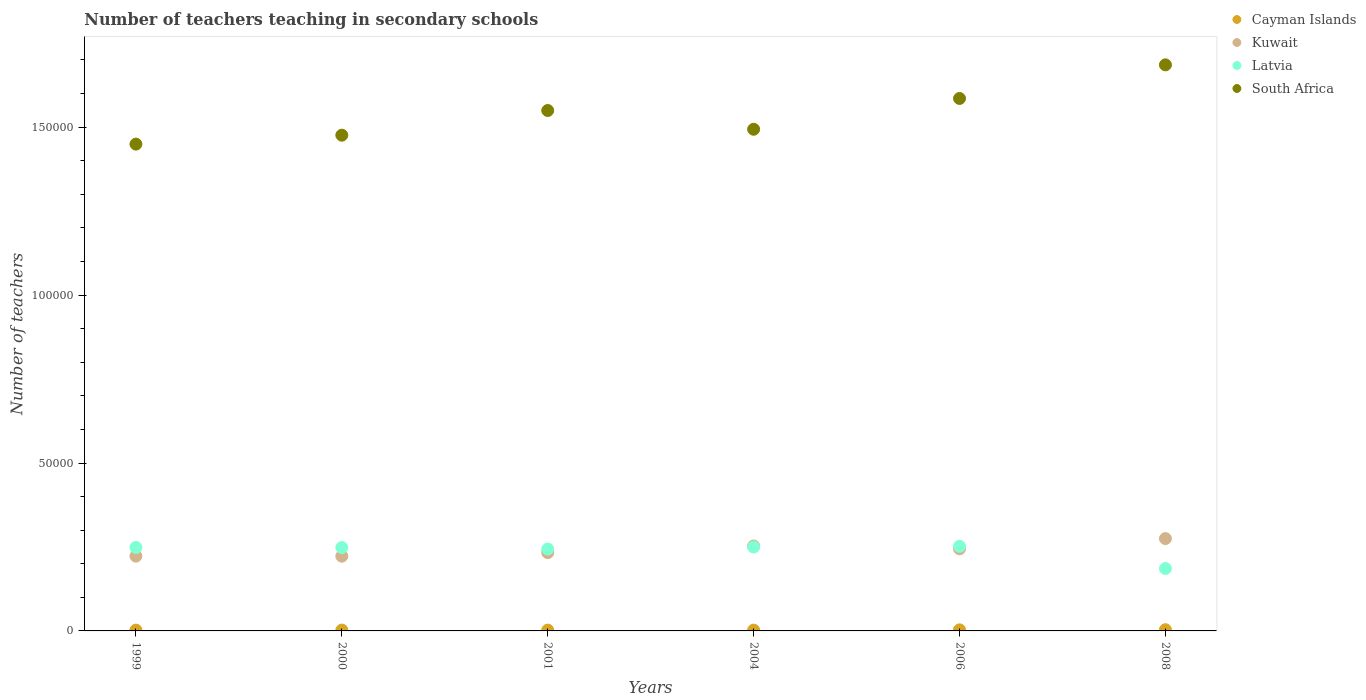How many different coloured dotlines are there?
Your answer should be compact. 4. What is the number of teachers teaching in secondary schools in Latvia in 2008?
Provide a succinct answer. 1.86e+04. Across all years, what is the maximum number of teachers teaching in secondary schools in Kuwait?
Your answer should be compact. 2.75e+04. Across all years, what is the minimum number of teachers teaching in secondary schools in Latvia?
Provide a succinct answer. 1.86e+04. In which year was the number of teachers teaching in secondary schools in Latvia minimum?
Your answer should be compact. 2008. What is the total number of teachers teaching in secondary schools in South Africa in the graph?
Keep it short and to the point. 9.24e+05. What is the difference between the number of teachers teaching in secondary schools in South Africa in 1999 and that in 2008?
Provide a short and direct response. -2.36e+04. What is the difference between the number of teachers teaching in secondary schools in Kuwait in 2004 and the number of teachers teaching in secondary schools in Cayman Islands in 2008?
Provide a succinct answer. 2.49e+04. What is the average number of teachers teaching in secondary schools in Cayman Islands per year?
Provide a succinct answer. 274. In the year 2006, what is the difference between the number of teachers teaching in secondary schools in Cayman Islands and number of teachers teaching in secondary schools in Kuwait?
Your response must be concise. -2.41e+04. What is the ratio of the number of teachers teaching in secondary schools in Kuwait in 2006 to that in 2008?
Make the answer very short. 0.89. What is the difference between the highest and the second highest number of teachers teaching in secondary schools in Latvia?
Ensure brevity in your answer.  213. What is the difference between the highest and the lowest number of teachers teaching in secondary schools in Latvia?
Make the answer very short. 6627. In how many years, is the number of teachers teaching in secondary schools in Kuwait greater than the average number of teachers teaching in secondary schools in Kuwait taken over all years?
Your answer should be compact. 3. Is it the case that in every year, the sum of the number of teachers teaching in secondary schools in South Africa and number of teachers teaching in secondary schools in Cayman Islands  is greater than the sum of number of teachers teaching in secondary schools in Kuwait and number of teachers teaching in secondary schools in Latvia?
Give a very brief answer. Yes. Does the number of teachers teaching in secondary schools in Latvia monotonically increase over the years?
Keep it short and to the point. No. What is the difference between two consecutive major ticks on the Y-axis?
Offer a terse response. 5.00e+04. Are the values on the major ticks of Y-axis written in scientific E-notation?
Your response must be concise. No. Does the graph contain any zero values?
Keep it short and to the point. No. Does the graph contain grids?
Make the answer very short. No. How many legend labels are there?
Keep it short and to the point. 4. How are the legend labels stacked?
Your answer should be very brief. Vertical. What is the title of the graph?
Provide a short and direct response. Number of teachers teaching in secondary schools. Does "Moldova" appear as one of the legend labels in the graph?
Your response must be concise. No. What is the label or title of the Y-axis?
Ensure brevity in your answer.  Number of teachers. What is the Number of teachers in Cayman Islands in 1999?
Offer a very short reply. 237. What is the Number of teachers in Kuwait in 1999?
Provide a short and direct response. 2.23e+04. What is the Number of teachers in Latvia in 1999?
Make the answer very short. 2.48e+04. What is the Number of teachers of South Africa in 1999?
Your response must be concise. 1.45e+05. What is the Number of teachers of Cayman Islands in 2000?
Offer a terse response. 252. What is the Number of teachers in Kuwait in 2000?
Make the answer very short. 2.22e+04. What is the Number of teachers in Latvia in 2000?
Your answer should be very brief. 2.48e+04. What is the Number of teachers in South Africa in 2000?
Ensure brevity in your answer.  1.48e+05. What is the Number of teachers in Cayman Islands in 2001?
Offer a very short reply. 239. What is the Number of teachers in Kuwait in 2001?
Your answer should be compact. 2.33e+04. What is the Number of teachers of Latvia in 2001?
Provide a succinct answer. 2.44e+04. What is the Number of teachers in South Africa in 2001?
Provide a succinct answer. 1.55e+05. What is the Number of teachers in Cayman Islands in 2004?
Give a very brief answer. 239. What is the Number of teachers in Kuwait in 2004?
Give a very brief answer. 2.53e+04. What is the Number of teachers in Latvia in 2004?
Your answer should be compact. 2.50e+04. What is the Number of teachers in South Africa in 2004?
Your answer should be very brief. 1.49e+05. What is the Number of teachers of Cayman Islands in 2006?
Your answer should be compact. 316. What is the Number of teachers in Kuwait in 2006?
Your response must be concise. 2.44e+04. What is the Number of teachers in Latvia in 2006?
Your response must be concise. 2.52e+04. What is the Number of teachers of South Africa in 2006?
Make the answer very short. 1.59e+05. What is the Number of teachers of Cayman Islands in 2008?
Keep it short and to the point. 361. What is the Number of teachers of Kuwait in 2008?
Ensure brevity in your answer.  2.75e+04. What is the Number of teachers in Latvia in 2008?
Offer a very short reply. 1.86e+04. What is the Number of teachers of South Africa in 2008?
Give a very brief answer. 1.69e+05. Across all years, what is the maximum Number of teachers of Cayman Islands?
Provide a succinct answer. 361. Across all years, what is the maximum Number of teachers in Kuwait?
Make the answer very short. 2.75e+04. Across all years, what is the maximum Number of teachers of Latvia?
Your answer should be compact. 2.52e+04. Across all years, what is the maximum Number of teachers of South Africa?
Keep it short and to the point. 1.69e+05. Across all years, what is the minimum Number of teachers of Cayman Islands?
Your answer should be compact. 237. Across all years, what is the minimum Number of teachers of Kuwait?
Your response must be concise. 2.22e+04. Across all years, what is the minimum Number of teachers in Latvia?
Give a very brief answer. 1.86e+04. Across all years, what is the minimum Number of teachers of South Africa?
Your answer should be compact. 1.45e+05. What is the total Number of teachers of Cayman Islands in the graph?
Offer a very short reply. 1644. What is the total Number of teachers of Kuwait in the graph?
Offer a very short reply. 1.45e+05. What is the total Number of teachers in Latvia in the graph?
Your answer should be compact. 1.43e+05. What is the total Number of teachers in South Africa in the graph?
Offer a very short reply. 9.24e+05. What is the difference between the Number of teachers of Kuwait in 1999 and that in 2000?
Give a very brief answer. 20. What is the difference between the Number of teachers of South Africa in 1999 and that in 2000?
Provide a short and direct response. -2663. What is the difference between the Number of teachers of Kuwait in 1999 and that in 2001?
Ensure brevity in your answer.  -1047. What is the difference between the Number of teachers of Latvia in 1999 and that in 2001?
Your answer should be compact. 463. What is the difference between the Number of teachers in South Africa in 1999 and that in 2001?
Your answer should be very brief. -1.00e+04. What is the difference between the Number of teachers in Kuwait in 1999 and that in 2004?
Your response must be concise. -3026. What is the difference between the Number of teachers in Latvia in 1999 and that in 2004?
Your response must be concise. -140. What is the difference between the Number of teachers of South Africa in 1999 and that in 2004?
Provide a succinct answer. -4426. What is the difference between the Number of teachers in Cayman Islands in 1999 and that in 2006?
Your answer should be compact. -79. What is the difference between the Number of teachers of Kuwait in 1999 and that in 2006?
Your response must be concise. -2178. What is the difference between the Number of teachers of Latvia in 1999 and that in 2006?
Provide a short and direct response. -353. What is the difference between the Number of teachers of South Africa in 1999 and that in 2006?
Your answer should be very brief. -1.36e+04. What is the difference between the Number of teachers of Cayman Islands in 1999 and that in 2008?
Give a very brief answer. -124. What is the difference between the Number of teachers of Kuwait in 1999 and that in 2008?
Ensure brevity in your answer.  -5232. What is the difference between the Number of teachers in Latvia in 1999 and that in 2008?
Provide a short and direct response. 6274. What is the difference between the Number of teachers of South Africa in 1999 and that in 2008?
Your answer should be compact. -2.36e+04. What is the difference between the Number of teachers of Kuwait in 2000 and that in 2001?
Provide a succinct answer. -1067. What is the difference between the Number of teachers of Latvia in 2000 and that in 2001?
Provide a short and direct response. 433. What is the difference between the Number of teachers of South Africa in 2000 and that in 2001?
Offer a terse response. -7348. What is the difference between the Number of teachers in Kuwait in 2000 and that in 2004?
Provide a succinct answer. -3046. What is the difference between the Number of teachers in Latvia in 2000 and that in 2004?
Your response must be concise. -170. What is the difference between the Number of teachers of South Africa in 2000 and that in 2004?
Ensure brevity in your answer.  -1763. What is the difference between the Number of teachers in Cayman Islands in 2000 and that in 2006?
Provide a succinct answer. -64. What is the difference between the Number of teachers in Kuwait in 2000 and that in 2006?
Provide a short and direct response. -2198. What is the difference between the Number of teachers in Latvia in 2000 and that in 2006?
Offer a terse response. -383. What is the difference between the Number of teachers in South Africa in 2000 and that in 2006?
Your response must be concise. -1.09e+04. What is the difference between the Number of teachers of Cayman Islands in 2000 and that in 2008?
Ensure brevity in your answer.  -109. What is the difference between the Number of teachers in Kuwait in 2000 and that in 2008?
Your answer should be very brief. -5252. What is the difference between the Number of teachers in Latvia in 2000 and that in 2008?
Offer a very short reply. 6244. What is the difference between the Number of teachers in South Africa in 2000 and that in 2008?
Provide a succinct answer. -2.09e+04. What is the difference between the Number of teachers of Cayman Islands in 2001 and that in 2004?
Offer a very short reply. 0. What is the difference between the Number of teachers of Kuwait in 2001 and that in 2004?
Offer a terse response. -1979. What is the difference between the Number of teachers of Latvia in 2001 and that in 2004?
Make the answer very short. -603. What is the difference between the Number of teachers in South Africa in 2001 and that in 2004?
Your response must be concise. 5585. What is the difference between the Number of teachers in Cayman Islands in 2001 and that in 2006?
Give a very brief answer. -77. What is the difference between the Number of teachers of Kuwait in 2001 and that in 2006?
Keep it short and to the point. -1131. What is the difference between the Number of teachers in Latvia in 2001 and that in 2006?
Ensure brevity in your answer.  -816. What is the difference between the Number of teachers in South Africa in 2001 and that in 2006?
Offer a terse response. -3584. What is the difference between the Number of teachers in Cayman Islands in 2001 and that in 2008?
Provide a succinct answer. -122. What is the difference between the Number of teachers in Kuwait in 2001 and that in 2008?
Your answer should be compact. -4185. What is the difference between the Number of teachers in Latvia in 2001 and that in 2008?
Offer a terse response. 5811. What is the difference between the Number of teachers in South Africa in 2001 and that in 2008?
Provide a succinct answer. -1.36e+04. What is the difference between the Number of teachers of Cayman Islands in 2004 and that in 2006?
Ensure brevity in your answer.  -77. What is the difference between the Number of teachers in Kuwait in 2004 and that in 2006?
Provide a succinct answer. 848. What is the difference between the Number of teachers of Latvia in 2004 and that in 2006?
Make the answer very short. -213. What is the difference between the Number of teachers of South Africa in 2004 and that in 2006?
Give a very brief answer. -9169. What is the difference between the Number of teachers in Cayman Islands in 2004 and that in 2008?
Your answer should be very brief. -122. What is the difference between the Number of teachers of Kuwait in 2004 and that in 2008?
Give a very brief answer. -2206. What is the difference between the Number of teachers in Latvia in 2004 and that in 2008?
Offer a terse response. 6414. What is the difference between the Number of teachers of South Africa in 2004 and that in 2008?
Give a very brief answer. -1.92e+04. What is the difference between the Number of teachers of Cayman Islands in 2006 and that in 2008?
Provide a short and direct response. -45. What is the difference between the Number of teachers of Kuwait in 2006 and that in 2008?
Offer a very short reply. -3054. What is the difference between the Number of teachers in Latvia in 2006 and that in 2008?
Provide a succinct answer. 6627. What is the difference between the Number of teachers in South Africa in 2006 and that in 2008?
Ensure brevity in your answer.  -1.00e+04. What is the difference between the Number of teachers of Cayman Islands in 1999 and the Number of teachers of Kuwait in 2000?
Your response must be concise. -2.20e+04. What is the difference between the Number of teachers in Cayman Islands in 1999 and the Number of teachers in Latvia in 2000?
Ensure brevity in your answer.  -2.46e+04. What is the difference between the Number of teachers in Cayman Islands in 1999 and the Number of teachers in South Africa in 2000?
Offer a terse response. -1.47e+05. What is the difference between the Number of teachers in Kuwait in 1999 and the Number of teachers in Latvia in 2000?
Offer a very short reply. -2555. What is the difference between the Number of teachers of Kuwait in 1999 and the Number of teachers of South Africa in 2000?
Offer a terse response. -1.25e+05. What is the difference between the Number of teachers of Latvia in 1999 and the Number of teachers of South Africa in 2000?
Your answer should be compact. -1.23e+05. What is the difference between the Number of teachers of Cayman Islands in 1999 and the Number of teachers of Kuwait in 2001?
Provide a short and direct response. -2.31e+04. What is the difference between the Number of teachers in Cayman Islands in 1999 and the Number of teachers in Latvia in 2001?
Your answer should be compact. -2.41e+04. What is the difference between the Number of teachers in Cayman Islands in 1999 and the Number of teachers in South Africa in 2001?
Keep it short and to the point. -1.55e+05. What is the difference between the Number of teachers in Kuwait in 1999 and the Number of teachers in Latvia in 2001?
Provide a succinct answer. -2122. What is the difference between the Number of teachers in Kuwait in 1999 and the Number of teachers in South Africa in 2001?
Give a very brief answer. -1.33e+05. What is the difference between the Number of teachers of Latvia in 1999 and the Number of teachers of South Africa in 2001?
Ensure brevity in your answer.  -1.30e+05. What is the difference between the Number of teachers in Cayman Islands in 1999 and the Number of teachers in Kuwait in 2004?
Provide a succinct answer. -2.51e+04. What is the difference between the Number of teachers in Cayman Islands in 1999 and the Number of teachers in Latvia in 2004?
Your response must be concise. -2.48e+04. What is the difference between the Number of teachers in Cayman Islands in 1999 and the Number of teachers in South Africa in 2004?
Ensure brevity in your answer.  -1.49e+05. What is the difference between the Number of teachers in Kuwait in 1999 and the Number of teachers in Latvia in 2004?
Make the answer very short. -2725. What is the difference between the Number of teachers of Kuwait in 1999 and the Number of teachers of South Africa in 2004?
Provide a succinct answer. -1.27e+05. What is the difference between the Number of teachers in Latvia in 1999 and the Number of teachers in South Africa in 2004?
Provide a succinct answer. -1.25e+05. What is the difference between the Number of teachers in Cayman Islands in 1999 and the Number of teachers in Kuwait in 2006?
Make the answer very short. -2.42e+04. What is the difference between the Number of teachers of Cayman Islands in 1999 and the Number of teachers of Latvia in 2006?
Give a very brief answer. -2.50e+04. What is the difference between the Number of teachers in Cayman Islands in 1999 and the Number of teachers in South Africa in 2006?
Offer a terse response. -1.58e+05. What is the difference between the Number of teachers in Kuwait in 1999 and the Number of teachers in Latvia in 2006?
Give a very brief answer. -2938. What is the difference between the Number of teachers in Kuwait in 1999 and the Number of teachers in South Africa in 2006?
Keep it short and to the point. -1.36e+05. What is the difference between the Number of teachers in Latvia in 1999 and the Number of teachers in South Africa in 2006?
Give a very brief answer. -1.34e+05. What is the difference between the Number of teachers in Cayman Islands in 1999 and the Number of teachers in Kuwait in 2008?
Make the answer very short. -2.73e+04. What is the difference between the Number of teachers of Cayman Islands in 1999 and the Number of teachers of Latvia in 2008?
Provide a succinct answer. -1.83e+04. What is the difference between the Number of teachers in Cayman Islands in 1999 and the Number of teachers in South Africa in 2008?
Provide a short and direct response. -1.68e+05. What is the difference between the Number of teachers of Kuwait in 1999 and the Number of teachers of Latvia in 2008?
Offer a terse response. 3689. What is the difference between the Number of teachers of Kuwait in 1999 and the Number of teachers of South Africa in 2008?
Offer a terse response. -1.46e+05. What is the difference between the Number of teachers of Latvia in 1999 and the Number of teachers of South Africa in 2008?
Your answer should be very brief. -1.44e+05. What is the difference between the Number of teachers of Cayman Islands in 2000 and the Number of teachers of Kuwait in 2001?
Your answer should be compact. -2.31e+04. What is the difference between the Number of teachers of Cayman Islands in 2000 and the Number of teachers of Latvia in 2001?
Give a very brief answer. -2.41e+04. What is the difference between the Number of teachers in Cayman Islands in 2000 and the Number of teachers in South Africa in 2001?
Offer a terse response. -1.55e+05. What is the difference between the Number of teachers of Kuwait in 2000 and the Number of teachers of Latvia in 2001?
Your answer should be very brief. -2142. What is the difference between the Number of teachers of Kuwait in 2000 and the Number of teachers of South Africa in 2001?
Ensure brevity in your answer.  -1.33e+05. What is the difference between the Number of teachers of Latvia in 2000 and the Number of teachers of South Africa in 2001?
Give a very brief answer. -1.30e+05. What is the difference between the Number of teachers in Cayman Islands in 2000 and the Number of teachers in Kuwait in 2004?
Keep it short and to the point. -2.50e+04. What is the difference between the Number of teachers of Cayman Islands in 2000 and the Number of teachers of Latvia in 2004?
Your answer should be compact. -2.47e+04. What is the difference between the Number of teachers of Cayman Islands in 2000 and the Number of teachers of South Africa in 2004?
Your response must be concise. -1.49e+05. What is the difference between the Number of teachers in Kuwait in 2000 and the Number of teachers in Latvia in 2004?
Make the answer very short. -2745. What is the difference between the Number of teachers of Kuwait in 2000 and the Number of teachers of South Africa in 2004?
Your answer should be compact. -1.27e+05. What is the difference between the Number of teachers of Latvia in 2000 and the Number of teachers of South Africa in 2004?
Your answer should be very brief. -1.25e+05. What is the difference between the Number of teachers of Cayman Islands in 2000 and the Number of teachers of Kuwait in 2006?
Your response must be concise. -2.42e+04. What is the difference between the Number of teachers in Cayman Islands in 2000 and the Number of teachers in Latvia in 2006?
Provide a succinct answer. -2.50e+04. What is the difference between the Number of teachers of Cayman Islands in 2000 and the Number of teachers of South Africa in 2006?
Your answer should be compact. -1.58e+05. What is the difference between the Number of teachers in Kuwait in 2000 and the Number of teachers in Latvia in 2006?
Provide a succinct answer. -2958. What is the difference between the Number of teachers in Kuwait in 2000 and the Number of teachers in South Africa in 2006?
Provide a short and direct response. -1.36e+05. What is the difference between the Number of teachers of Latvia in 2000 and the Number of teachers of South Africa in 2006?
Give a very brief answer. -1.34e+05. What is the difference between the Number of teachers in Cayman Islands in 2000 and the Number of teachers in Kuwait in 2008?
Provide a succinct answer. -2.72e+04. What is the difference between the Number of teachers in Cayman Islands in 2000 and the Number of teachers in Latvia in 2008?
Offer a very short reply. -1.83e+04. What is the difference between the Number of teachers of Cayman Islands in 2000 and the Number of teachers of South Africa in 2008?
Your response must be concise. -1.68e+05. What is the difference between the Number of teachers in Kuwait in 2000 and the Number of teachers in Latvia in 2008?
Offer a terse response. 3669. What is the difference between the Number of teachers of Kuwait in 2000 and the Number of teachers of South Africa in 2008?
Your response must be concise. -1.46e+05. What is the difference between the Number of teachers in Latvia in 2000 and the Number of teachers in South Africa in 2008?
Your answer should be very brief. -1.44e+05. What is the difference between the Number of teachers of Cayman Islands in 2001 and the Number of teachers of Kuwait in 2004?
Offer a very short reply. -2.51e+04. What is the difference between the Number of teachers in Cayman Islands in 2001 and the Number of teachers in Latvia in 2004?
Your answer should be very brief. -2.48e+04. What is the difference between the Number of teachers in Cayman Islands in 2001 and the Number of teachers in South Africa in 2004?
Give a very brief answer. -1.49e+05. What is the difference between the Number of teachers of Kuwait in 2001 and the Number of teachers of Latvia in 2004?
Provide a succinct answer. -1678. What is the difference between the Number of teachers of Kuwait in 2001 and the Number of teachers of South Africa in 2004?
Offer a terse response. -1.26e+05. What is the difference between the Number of teachers of Latvia in 2001 and the Number of teachers of South Africa in 2004?
Offer a terse response. -1.25e+05. What is the difference between the Number of teachers in Cayman Islands in 2001 and the Number of teachers in Kuwait in 2006?
Ensure brevity in your answer.  -2.42e+04. What is the difference between the Number of teachers in Cayman Islands in 2001 and the Number of teachers in Latvia in 2006?
Your answer should be very brief. -2.50e+04. What is the difference between the Number of teachers of Cayman Islands in 2001 and the Number of teachers of South Africa in 2006?
Keep it short and to the point. -1.58e+05. What is the difference between the Number of teachers in Kuwait in 2001 and the Number of teachers in Latvia in 2006?
Your response must be concise. -1891. What is the difference between the Number of teachers of Kuwait in 2001 and the Number of teachers of South Africa in 2006?
Offer a very short reply. -1.35e+05. What is the difference between the Number of teachers of Latvia in 2001 and the Number of teachers of South Africa in 2006?
Provide a short and direct response. -1.34e+05. What is the difference between the Number of teachers in Cayman Islands in 2001 and the Number of teachers in Kuwait in 2008?
Your answer should be compact. -2.73e+04. What is the difference between the Number of teachers of Cayman Islands in 2001 and the Number of teachers of Latvia in 2008?
Give a very brief answer. -1.83e+04. What is the difference between the Number of teachers of Cayman Islands in 2001 and the Number of teachers of South Africa in 2008?
Your answer should be very brief. -1.68e+05. What is the difference between the Number of teachers of Kuwait in 2001 and the Number of teachers of Latvia in 2008?
Provide a succinct answer. 4736. What is the difference between the Number of teachers in Kuwait in 2001 and the Number of teachers in South Africa in 2008?
Provide a short and direct response. -1.45e+05. What is the difference between the Number of teachers in Latvia in 2001 and the Number of teachers in South Africa in 2008?
Provide a short and direct response. -1.44e+05. What is the difference between the Number of teachers in Cayman Islands in 2004 and the Number of teachers in Kuwait in 2006?
Make the answer very short. -2.42e+04. What is the difference between the Number of teachers of Cayman Islands in 2004 and the Number of teachers of Latvia in 2006?
Make the answer very short. -2.50e+04. What is the difference between the Number of teachers of Cayman Islands in 2004 and the Number of teachers of South Africa in 2006?
Give a very brief answer. -1.58e+05. What is the difference between the Number of teachers in Kuwait in 2004 and the Number of teachers in Latvia in 2006?
Your answer should be very brief. 88. What is the difference between the Number of teachers in Kuwait in 2004 and the Number of teachers in South Africa in 2006?
Offer a terse response. -1.33e+05. What is the difference between the Number of teachers in Latvia in 2004 and the Number of teachers in South Africa in 2006?
Make the answer very short. -1.34e+05. What is the difference between the Number of teachers in Cayman Islands in 2004 and the Number of teachers in Kuwait in 2008?
Ensure brevity in your answer.  -2.73e+04. What is the difference between the Number of teachers in Cayman Islands in 2004 and the Number of teachers in Latvia in 2008?
Your answer should be compact. -1.83e+04. What is the difference between the Number of teachers in Cayman Islands in 2004 and the Number of teachers in South Africa in 2008?
Provide a short and direct response. -1.68e+05. What is the difference between the Number of teachers of Kuwait in 2004 and the Number of teachers of Latvia in 2008?
Provide a succinct answer. 6715. What is the difference between the Number of teachers in Kuwait in 2004 and the Number of teachers in South Africa in 2008?
Ensure brevity in your answer.  -1.43e+05. What is the difference between the Number of teachers in Latvia in 2004 and the Number of teachers in South Africa in 2008?
Provide a succinct answer. -1.44e+05. What is the difference between the Number of teachers of Cayman Islands in 2006 and the Number of teachers of Kuwait in 2008?
Provide a succinct answer. -2.72e+04. What is the difference between the Number of teachers in Cayman Islands in 2006 and the Number of teachers in Latvia in 2008?
Ensure brevity in your answer.  -1.83e+04. What is the difference between the Number of teachers of Cayman Islands in 2006 and the Number of teachers of South Africa in 2008?
Make the answer very short. -1.68e+05. What is the difference between the Number of teachers of Kuwait in 2006 and the Number of teachers of Latvia in 2008?
Provide a short and direct response. 5867. What is the difference between the Number of teachers of Kuwait in 2006 and the Number of teachers of South Africa in 2008?
Give a very brief answer. -1.44e+05. What is the difference between the Number of teachers of Latvia in 2006 and the Number of teachers of South Africa in 2008?
Offer a terse response. -1.43e+05. What is the average Number of teachers in Cayman Islands per year?
Keep it short and to the point. 274. What is the average Number of teachers in Kuwait per year?
Make the answer very short. 2.42e+04. What is the average Number of teachers of Latvia per year?
Your answer should be compact. 2.38e+04. What is the average Number of teachers in South Africa per year?
Make the answer very short. 1.54e+05. In the year 1999, what is the difference between the Number of teachers in Cayman Islands and Number of teachers in Kuwait?
Your answer should be very brief. -2.20e+04. In the year 1999, what is the difference between the Number of teachers of Cayman Islands and Number of teachers of Latvia?
Provide a succinct answer. -2.46e+04. In the year 1999, what is the difference between the Number of teachers in Cayman Islands and Number of teachers in South Africa?
Your answer should be very brief. -1.45e+05. In the year 1999, what is the difference between the Number of teachers of Kuwait and Number of teachers of Latvia?
Your answer should be very brief. -2585. In the year 1999, what is the difference between the Number of teachers in Kuwait and Number of teachers in South Africa?
Offer a very short reply. -1.23e+05. In the year 1999, what is the difference between the Number of teachers of Latvia and Number of teachers of South Africa?
Offer a terse response. -1.20e+05. In the year 2000, what is the difference between the Number of teachers of Cayman Islands and Number of teachers of Kuwait?
Ensure brevity in your answer.  -2.20e+04. In the year 2000, what is the difference between the Number of teachers in Cayman Islands and Number of teachers in Latvia?
Give a very brief answer. -2.46e+04. In the year 2000, what is the difference between the Number of teachers in Cayman Islands and Number of teachers in South Africa?
Keep it short and to the point. -1.47e+05. In the year 2000, what is the difference between the Number of teachers in Kuwait and Number of teachers in Latvia?
Provide a short and direct response. -2575. In the year 2000, what is the difference between the Number of teachers in Kuwait and Number of teachers in South Africa?
Make the answer very short. -1.25e+05. In the year 2000, what is the difference between the Number of teachers in Latvia and Number of teachers in South Africa?
Provide a short and direct response. -1.23e+05. In the year 2001, what is the difference between the Number of teachers of Cayman Islands and Number of teachers of Kuwait?
Provide a short and direct response. -2.31e+04. In the year 2001, what is the difference between the Number of teachers in Cayman Islands and Number of teachers in Latvia?
Make the answer very short. -2.41e+04. In the year 2001, what is the difference between the Number of teachers in Cayman Islands and Number of teachers in South Africa?
Offer a terse response. -1.55e+05. In the year 2001, what is the difference between the Number of teachers in Kuwait and Number of teachers in Latvia?
Your answer should be very brief. -1075. In the year 2001, what is the difference between the Number of teachers in Kuwait and Number of teachers in South Africa?
Provide a succinct answer. -1.32e+05. In the year 2001, what is the difference between the Number of teachers of Latvia and Number of teachers of South Africa?
Keep it short and to the point. -1.31e+05. In the year 2004, what is the difference between the Number of teachers of Cayman Islands and Number of teachers of Kuwait?
Provide a succinct answer. -2.51e+04. In the year 2004, what is the difference between the Number of teachers in Cayman Islands and Number of teachers in Latvia?
Your answer should be very brief. -2.48e+04. In the year 2004, what is the difference between the Number of teachers of Cayman Islands and Number of teachers of South Africa?
Make the answer very short. -1.49e+05. In the year 2004, what is the difference between the Number of teachers in Kuwait and Number of teachers in Latvia?
Your response must be concise. 301. In the year 2004, what is the difference between the Number of teachers of Kuwait and Number of teachers of South Africa?
Keep it short and to the point. -1.24e+05. In the year 2004, what is the difference between the Number of teachers of Latvia and Number of teachers of South Africa?
Your response must be concise. -1.24e+05. In the year 2006, what is the difference between the Number of teachers of Cayman Islands and Number of teachers of Kuwait?
Offer a terse response. -2.41e+04. In the year 2006, what is the difference between the Number of teachers of Cayman Islands and Number of teachers of Latvia?
Your answer should be compact. -2.49e+04. In the year 2006, what is the difference between the Number of teachers of Cayman Islands and Number of teachers of South Africa?
Your response must be concise. -1.58e+05. In the year 2006, what is the difference between the Number of teachers in Kuwait and Number of teachers in Latvia?
Offer a very short reply. -760. In the year 2006, what is the difference between the Number of teachers in Kuwait and Number of teachers in South Africa?
Keep it short and to the point. -1.34e+05. In the year 2006, what is the difference between the Number of teachers in Latvia and Number of teachers in South Africa?
Your response must be concise. -1.33e+05. In the year 2008, what is the difference between the Number of teachers of Cayman Islands and Number of teachers of Kuwait?
Give a very brief answer. -2.71e+04. In the year 2008, what is the difference between the Number of teachers in Cayman Islands and Number of teachers in Latvia?
Offer a terse response. -1.82e+04. In the year 2008, what is the difference between the Number of teachers in Cayman Islands and Number of teachers in South Africa?
Your answer should be very brief. -1.68e+05. In the year 2008, what is the difference between the Number of teachers of Kuwait and Number of teachers of Latvia?
Provide a succinct answer. 8921. In the year 2008, what is the difference between the Number of teachers of Kuwait and Number of teachers of South Africa?
Keep it short and to the point. -1.41e+05. In the year 2008, what is the difference between the Number of teachers of Latvia and Number of teachers of South Africa?
Your response must be concise. -1.50e+05. What is the ratio of the Number of teachers in Cayman Islands in 1999 to that in 2000?
Give a very brief answer. 0.94. What is the ratio of the Number of teachers of Latvia in 1999 to that in 2000?
Ensure brevity in your answer.  1. What is the ratio of the Number of teachers of South Africa in 1999 to that in 2000?
Ensure brevity in your answer.  0.98. What is the ratio of the Number of teachers in Cayman Islands in 1999 to that in 2001?
Provide a succinct answer. 0.99. What is the ratio of the Number of teachers in Kuwait in 1999 to that in 2001?
Give a very brief answer. 0.96. What is the ratio of the Number of teachers in South Africa in 1999 to that in 2001?
Your response must be concise. 0.94. What is the ratio of the Number of teachers of Cayman Islands in 1999 to that in 2004?
Provide a succinct answer. 0.99. What is the ratio of the Number of teachers of Kuwait in 1999 to that in 2004?
Ensure brevity in your answer.  0.88. What is the ratio of the Number of teachers in South Africa in 1999 to that in 2004?
Ensure brevity in your answer.  0.97. What is the ratio of the Number of teachers in Kuwait in 1999 to that in 2006?
Provide a short and direct response. 0.91. What is the ratio of the Number of teachers of Latvia in 1999 to that in 2006?
Provide a succinct answer. 0.99. What is the ratio of the Number of teachers in South Africa in 1999 to that in 2006?
Your answer should be compact. 0.91. What is the ratio of the Number of teachers in Cayman Islands in 1999 to that in 2008?
Keep it short and to the point. 0.66. What is the ratio of the Number of teachers of Kuwait in 1999 to that in 2008?
Your answer should be compact. 0.81. What is the ratio of the Number of teachers of Latvia in 1999 to that in 2008?
Provide a short and direct response. 1.34. What is the ratio of the Number of teachers in South Africa in 1999 to that in 2008?
Ensure brevity in your answer.  0.86. What is the ratio of the Number of teachers in Cayman Islands in 2000 to that in 2001?
Offer a very short reply. 1.05. What is the ratio of the Number of teachers in Kuwait in 2000 to that in 2001?
Your response must be concise. 0.95. What is the ratio of the Number of teachers in Latvia in 2000 to that in 2001?
Your answer should be very brief. 1.02. What is the ratio of the Number of teachers of South Africa in 2000 to that in 2001?
Provide a succinct answer. 0.95. What is the ratio of the Number of teachers in Cayman Islands in 2000 to that in 2004?
Keep it short and to the point. 1.05. What is the ratio of the Number of teachers in Kuwait in 2000 to that in 2004?
Your response must be concise. 0.88. What is the ratio of the Number of teachers in Cayman Islands in 2000 to that in 2006?
Provide a short and direct response. 0.8. What is the ratio of the Number of teachers of Kuwait in 2000 to that in 2006?
Your answer should be compact. 0.91. What is the ratio of the Number of teachers in Cayman Islands in 2000 to that in 2008?
Provide a short and direct response. 0.7. What is the ratio of the Number of teachers of Kuwait in 2000 to that in 2008?
Offer a terse response. 0.81. What is the ratio of the Number of teachers in Latvia in 2000 to that in 2008?
Provide a short and direct response. 1.34. What is the ratio of the Number of teachers of South Africa in 2000 to that in 2008?
Your response must be concise. 0.88. What is the ratio of the Number of teachers in Kuwait in 2001 to that in 2004?
Keep it short and to the point. 0.92. What is the ratio of the Number of teachers in Latvia in 2001 to that in 2004?
Your answer should be compact. 0.98. What is the ratio of the Number of teachers in South Africa in 2001 to that in 2004?
Your answer should be compact. 1.04. What is the ratio of the Number of teachers of Cayman Islands in 2001 to that in 2006?
Provide a short and direct response. 0.76. What is the ratio of the Number of teachers of Kuwait in 2001 to that in 2006?
Your response must be concise. 0.95. What is the ratio of the Number of teachers in Latvia in 2001 to that in 2006?
Your response must be concise. 0.97. What is the ratio of the Number of teachers in South Africa in 2001 to that in 2006?
Provide a short and direct response. 0.98. What is the ratio of the Number of teachers in Cayman Islands in 2001 to that in 2008?
Make the answer very short. 0.66. What is the ratio of the Number of teachers of Kuwait in 2001 to that in 2008?
Provide a short and direct response. 0.85. What is the ratio of the Number of teachers in Latvia in 2001 to that in 2008?
Provide a short and direct response. 1.31. What is the ratio of the Number of teachers in South Africa in 2001 to that in 2008?
Your answer should be very brief. 0.92. What is the ratio of the Number of teachers of Cayman Islands in 2004 to that in 2006?
Provide a succinct answer. 0.76. What is the ratio of the Number of teachers of Kuwait in 2004 to that in 2006?
Provide a succinct answer. 1.03. What is the ratio of the Number of teachers of Latvia in 2004 to that in 2006?
Give a very brief answer. 0.99. What is the ratio of the Number of teachers in South Africa in 2004 to that in 2006?
Offer a very short reply. 0.94. What is the ratio of the Number of teachers of Cayman Islands in 2004 to that in 2008?
Give a very brief answer. 0.66. What is the ratio of the Number of teachers of Kuwait in 2004 to that in 2008?
Provide a short and direct response. 0.92. What is the ratio of the Number of teachers in Latvia in 2004 to that in 2008?
Give a very brief answer. 1.35. What is the ratio of the Number of teachers in South Africa in 2004 to that in 2008?
Give a very brief answer. 0.89. What is the ratio of the Number of teachers of Cayman Islands in 2006 to that in 2008?
Offer a terse response. 0.88. What is the ratio of the Number of teachers of Kuwait in 2006 to that in 2008?
Give a very brief answer. 0.89. What is the ratio of the Number of teachers in Latvia in 2006 to that in 2008?
Keep it short and to the point. 1.36. What is the ratio of the Number of teachers in South Africa in 2006 to that in 2008?
Offer a terse response. 0.94. What is the difference between the highest and the second highest Number of teachers of Kuwait?
Your answer should be very brief. 2206. What is the difference between the highest and the second highest Number of teachers in Latvia?
Your response must be concise. 213. What is the difference between the highest and the second highest Number of teachers of South Africa?
Keep it short and to the point. 1.00e+04. What is the difference between the highest and the lowest Number of teachers in Cayman Islands?
Keep it short and to the point. 124. What is the difference between the highest and the lowest Number of teachers of Kuwait?
Ensure brevity in your answer.  5252. What is the difference between the highest and the lowest Number of teachers of Latvia?
Provide a short and direct response. 6627. What is the difference between the highest and the lowest Number of teachers of South Africa?
Your response must be concise. 2.36e+04. 